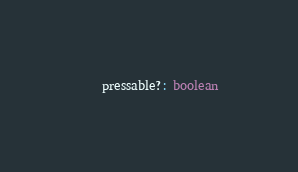Convert code to text. <code><loc_0><loc_0><loc_500><loc_500><_TypeScript_>	pressable?: boolean</code> 